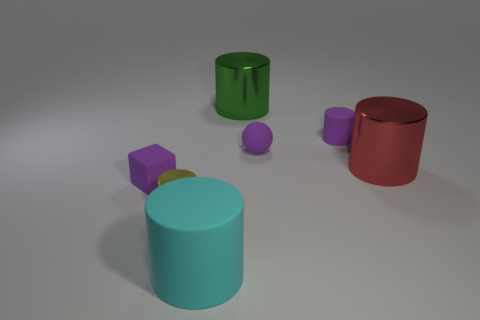There is a cyan thing that is made of the same material as the tiny purple cylinder; what shape is it?
Your response must be concise. Cylinder. What number of metal things are big cylinders or tiny yellow cylinders?
Your answer should be compact. 3. Are there an equal number of yellow shiny cylinders that are behind the big green cylinder and big matte objects?
Your answer should be very brief. No. There is a metallic object that is on the left side of the big green shiny thing; is its color the same as the big rubber thing?
Ensure brevity in your answer.  No. What is the material of the tiny thing that is both to the left of the tiny purple matte sphere and behind the yellow cylinder?
Give a very brief answer. Rubber. Are there any spheres to the left of the large cylinder to the right of the big green metal thing?
Offer a very short reply. Yes. Is the cyan thing made of the same material as the large red cylinder?
Make the answer very short. No. There is a small object that is both behind the tiny yellow metal object and left of the green metal cylinder; what shape is it?
Offer a terse response. Cube. There is a purple object that is to the left of the cylinder in front of the small metallic cylinder; what size is it?
Give a very brief answer. Small. What number of other metallic objects have the same shape as the big red thing?
Give a very brief answer. 2. 